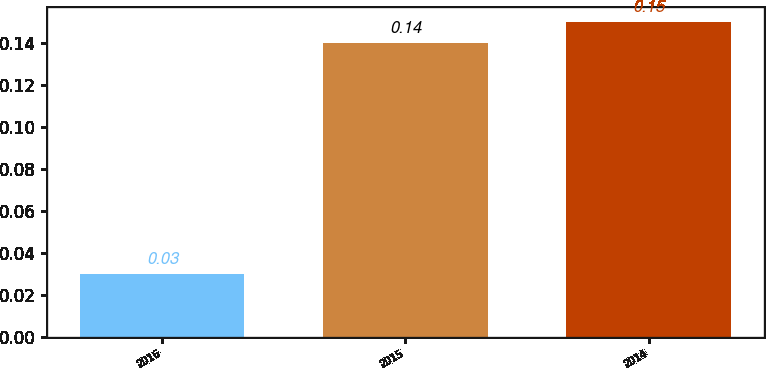Convert chart to OTSL. <chart><loc_0><loc_0><loc_500><loc_500><bar_chart><fcel>2016<fcel>2015<fcel>2014<nl><fcel>0.03<fcel>0.14<fcel>0.15<nl></chart> 